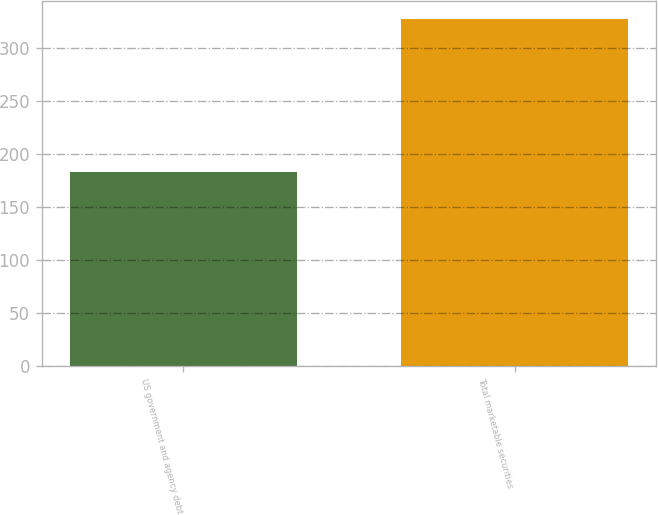Convert chart. <chart><loc_0><loc_0><loc_500><loc_500><bar_chart><fcel>US government and agency debt<fcel>Total marketable securities<nl><fcel>183<fcel>328<nl></chart> 